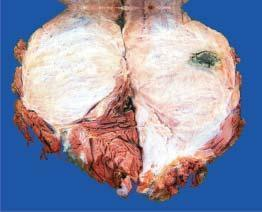what is grey-white fleshy with areas of haemorrhage and necrosis?
Answer the question using a single word or phrase. Cut surface 